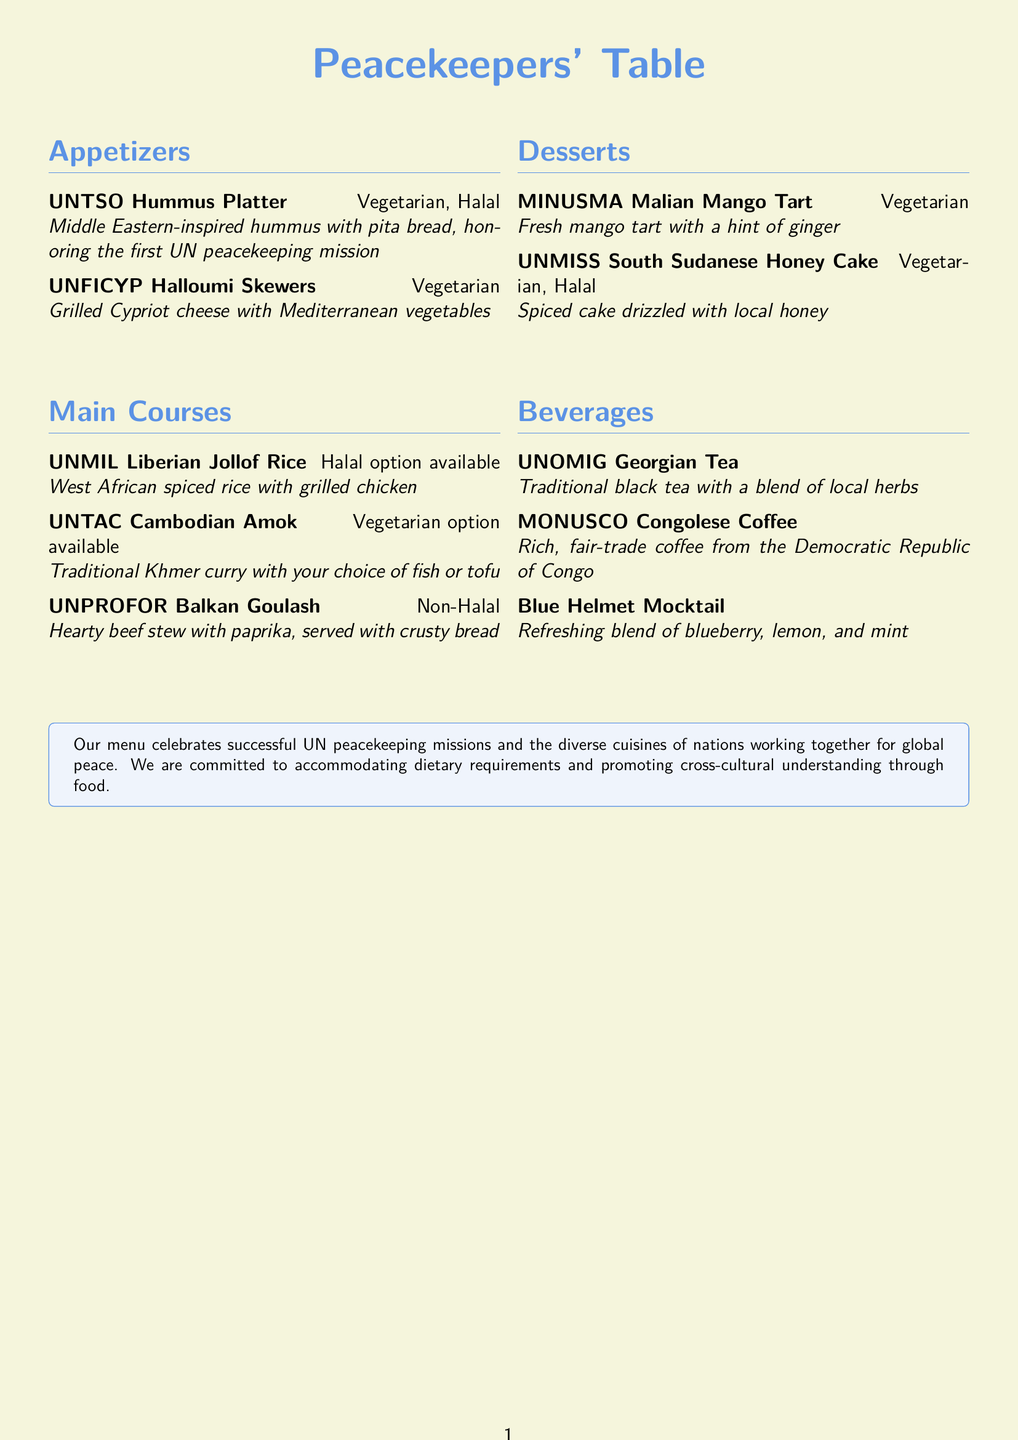What is the name of the first UN peacekeeping mission honored in the menu? The first UN peacekeeping mission is recognized by the UNTSO Hummus Platter.
Answer: UNTSO Hummus Platter Which appetizer is vegetarian? The document lists UNTSO Hummus Platter and UNFICYP Halloumi Skewers as vegetarian options.
Answer: UNTSO Hummus Platter and UNFICYP Halloumi Skewers How many desserts are listed in the menu? The document includes two dessert options: MINUSMA Malian Mango Tart and UNMISS South Sudanese Honey Cake.
Answer: Two What is the style of the UNMIL dish? The dish is described as West African spiced rice.
Answer: West African spiced rice Which item offers a halal option? The UNMIL dish includes a halal option for diners.
Answer: UNMIL Liberian Jollof Rice What beverage features a non-alcoholic option? The document specifies a mocktail, which is a non-alcoholic drink.
Answer: Blue Helmet Mocktail What type of tea is listed in the beverage section? The menu lists a traditional black tea in the beverages.
Answer: Traditional black tea Which course has a non-halal dish? The document indicates that UNPROFOR Balkan Goulash is a non-halal option.
Answer: UNPROFOR Balkan Goulash 